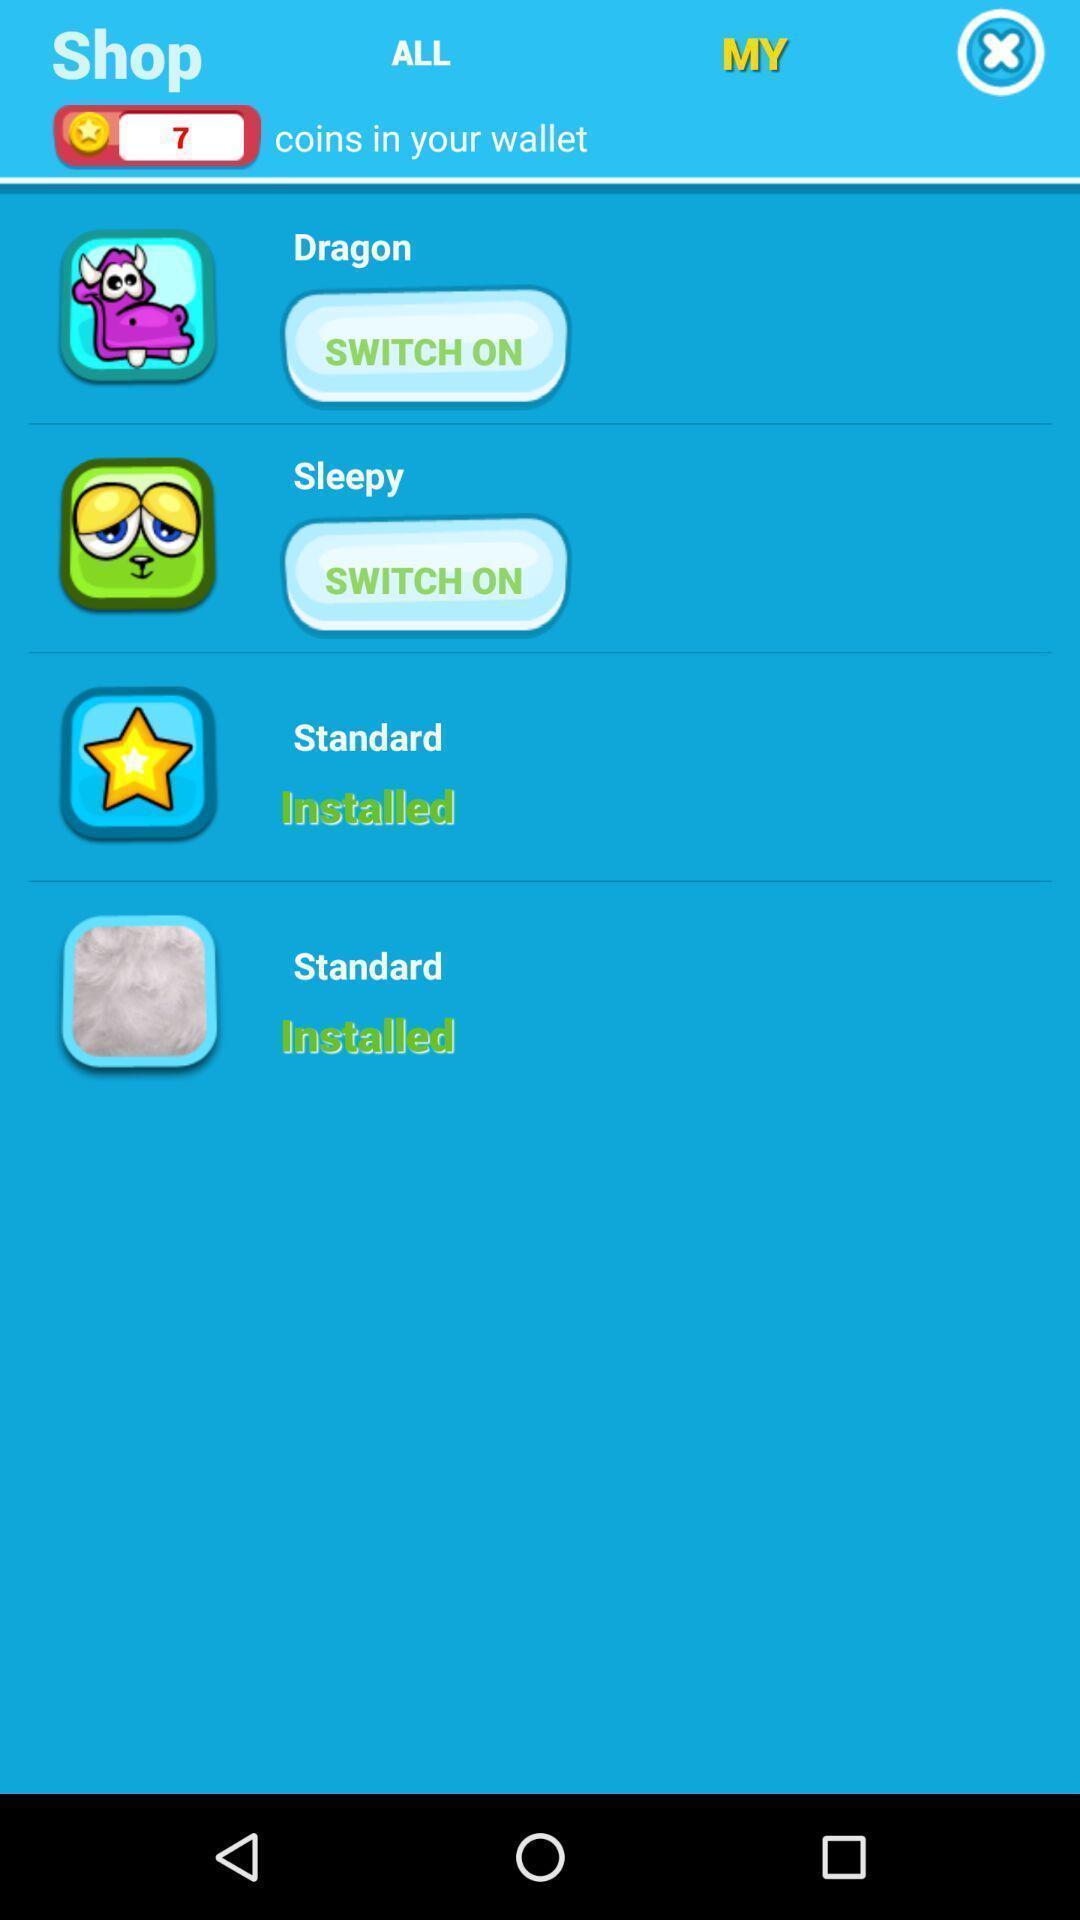What is the overall content of this screenshot? Window displaying to earn rewards in gam. 